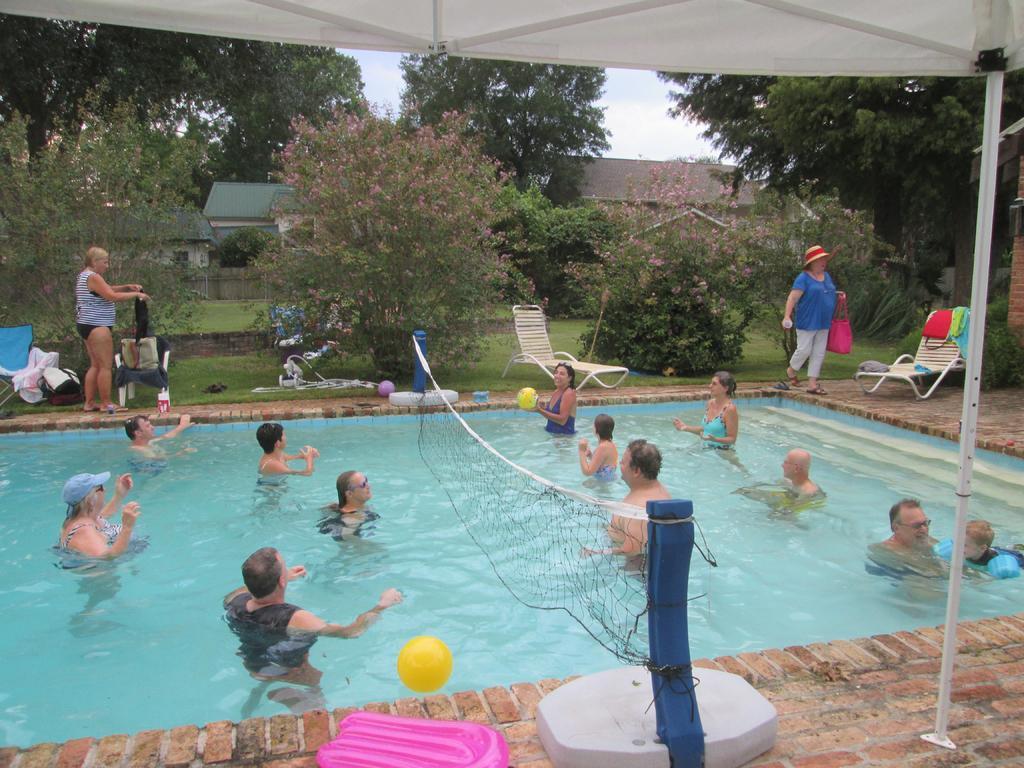In one or two sentences, can you explain what this image depicts? In this image there are people in the water. There is a net tied to the poles. There is a woman holding a ball. There is a ball in the air. There is a balloon on the floor having a pole. There are chairs on the floor. There is a ball and few objects on the grassland having plants. Background there are houses and trees. Behind there is sky. Top of the image there is a tent. 